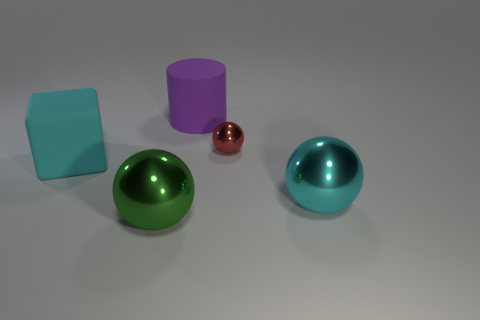What number of yellow objects are there?
Provide a succinct answer. 0. Does the large thing that is right of the purple cylinder have the same material as the small thing right of the purple cylinder?
Make the answer very short. Yes. The tiny object that is the same shape as the large green metallic object is what color?
Provide a short and direct response. Red. What material is the red thing in front of the matte thing that is behind the big cyan rubber object?
Offer a terse response. Metal. There is a large thing that is behind the small red thing; does it have the same shape as the cyan object on the right side of the tiny shiny object?
Provide a succinct answer. No. How big is the object that is to the left of the tiny object and behind the cyan block?
Provide a short and direct response. Large. How many other objects are the same color as the tiny metallic thing?
Offer a terse response. 0. Does the sphere that is to the right of the red thing have the same material as the big cylinder?
Your answer should be compact. No. Are there any other things that are the same size as the red shiny sphere?
Offer a terse response. No. Are there fewer small objects that are behind the red metal sphere than green objects in front of the big matte cylinder?
Offer a very short reply. Yes. 